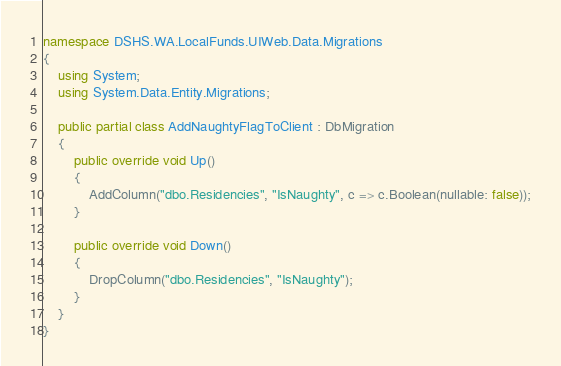<code> <loc_0><loc_0><loc_500><loc_500><_C#_>namespace DSHS.WA.LocalFunds.UIWeb.Data.Migrations
{
    using System;
    using System.Data.Entity.Migrations;
    
    public partial class AddNaughtyFlagToClient : DbMigration
    {
        public override void Up()
        {
            AddColumn("dbo.Residencies", "IsNaughty", c => c.Boolean(nullable: false));
        }
        
        public override void Down()
        {
            DropColumn("dbo.Residencies", "IsNaughty");
        }
    }
}
</code> 